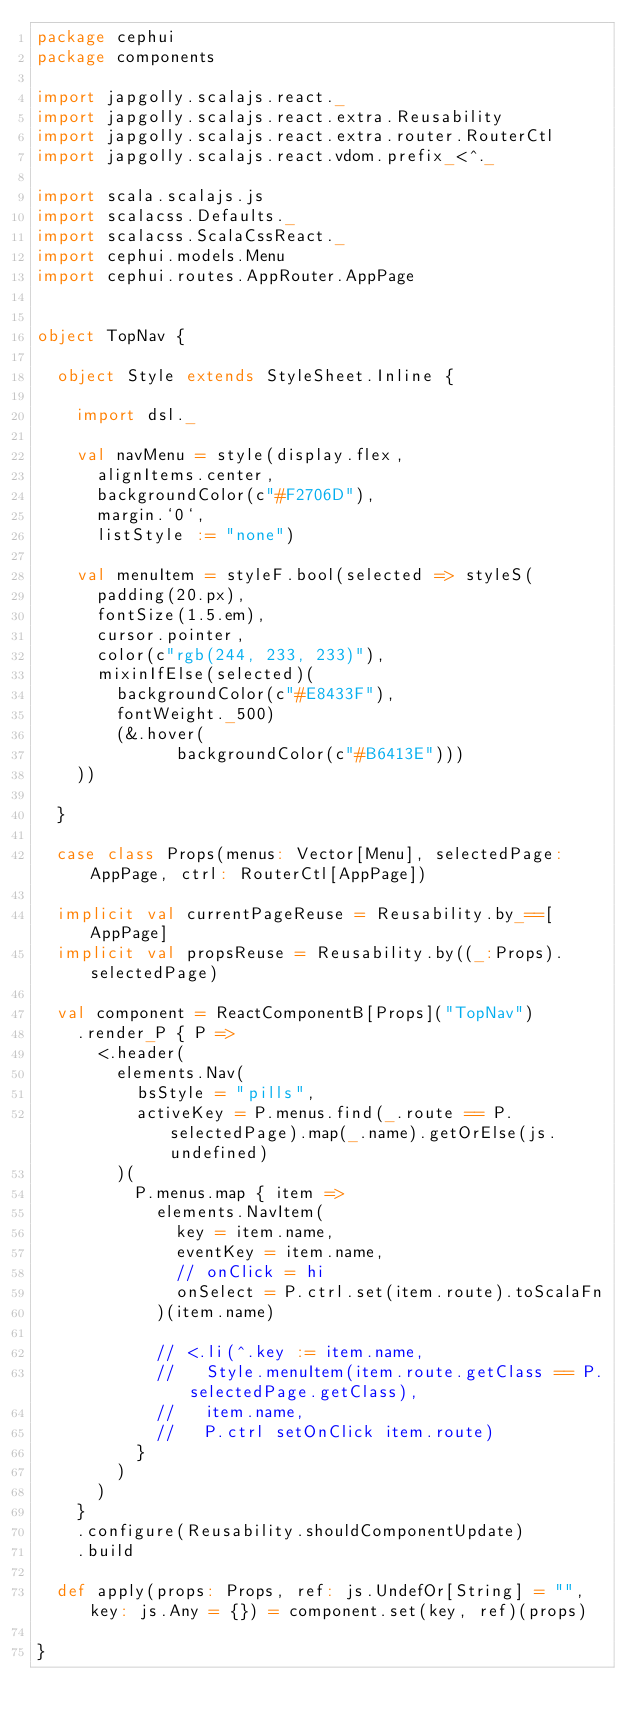<code> <loc_0><loc_0><loc_500><loc_500><_Scala_>package cephui
package components

import japgolly.scalajs.react._
import japgolly.scalajs.react.extra.Reusability
import japgolly.scalajs.react.extra.router.RouterCtl
import japgolly.scalajs.react.vdom.prefix_<^._

import scala.scalajs.js
import scalacss.Defaults._
import scalacss.ScalaCssReact._
import cephui.models.Menu
import cephui.routes.AppRouter.AppPage


object TopNav {

  object Style extends StyleSheet.Inline {

    import dsl._

    val navMenu = style(display.flex,
      alignItems.center,
      backgroundColor(c"#F2706D"),
      margin.`0`,
      listStyle := "none")

    val menuItem = styleF.bool(selected => styleS(
      padding(20.px),
      fontSize(1.5.em),
      cursor.pointer,
      color(c"rgb(244, 233, 233)"),
      mixinIfElse(selected)(
        backgroundColor(c"#E8433F"),
        fontWeight._500)
        (&.hover(
              backgroundColor(c"#B6413E")))
    ))

  }

  case class Props(menus: Vector[Menu], selectedPage: AppPage, ctrl: RouterCtl[AppPage])

  implicit val currentPageReuse = Reusability.by_==[AppPage]
  implicit val propsReuse = Reusability.by((_:Props).selectedPage)

  val component = ReactComponentB[Props]("TopNav")
    .render_P { P =>
      <.header(
        elements.Nav(
          bsStyle = "pills",
          activeKey = P.menus.find(_.route == P.selectedPage).map(_.name).getOrElse(js.undefined)
        )(
          P.menus.map { item =>
            elements.NavItem(
              key = item.name,
              eventKey = item.name,
              // onClick = hi
              onSelect = P.ctrl.set(item.route).toScalaFn
            )(item.name)

            // <.li(^.key := item.name,
            //   Style.menuItem(item.route.getClass == P.selectedPage.getClass),
            //   item.name,
            //   P.ctrl setOnClick item.route)
          }
        )
      )
    }
    .configure(Reusability.shouldComponentUpdate)
    .build

  def apply(props: Props, ref: js.UndefOr[String] = "", key: js.Any = {}) = component.set(key, ref)(props)

}
</code> 